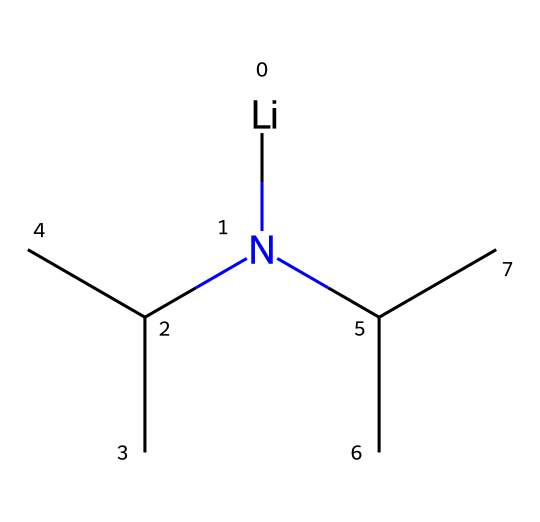What is the central atom in lithium diisopropylamide? The SMILES notation indicates the presence of lithium, shown at the beginning of the representation. This is the only metal in the structure, making it the central atom.
Answer: lithium How many isopropyl groups are attached to the nitrogen in lithium diisopropylamide? By analyzing the SMILES representation, we see two sets of "C(C)C" indicating two isopropyl groups (each one consists of three carbon atoms and one nitrogen bond).
Answer: 2 What type of functional group is present in this compound? The nitrogen atom connected to carbon groups characterizes this compound as an amine, with the nitrogen atom providing the amine functionality.
Answer: amine How many carbon atoms are there in lithium diisopropylamide? The structure shows two isopropyl groups, each containing three carbon atoms, totaling six. The lithium and nitrogen atoms do not contribute additional carbon atoms.
Answer: 6 Why is lithium diisopropylamide categorized as a superbase? The strong basicity of lithium diisopropylamide is due to the presence of a nitrogen atom that can accept protons effectively, resulting in high reactivity with electrophiles.
Answer: strong basicity What role does lithium play in lithium diisopropylamide? Lithium serves as a counterion that stabilizes the negatively charged nitrogen atom after it deprotonates substrates, enhancing the overall basicity of the compound.
Answer: counterion 